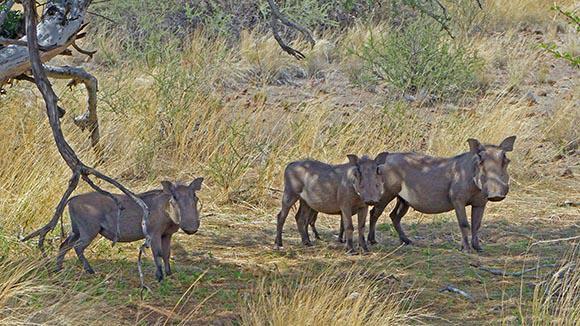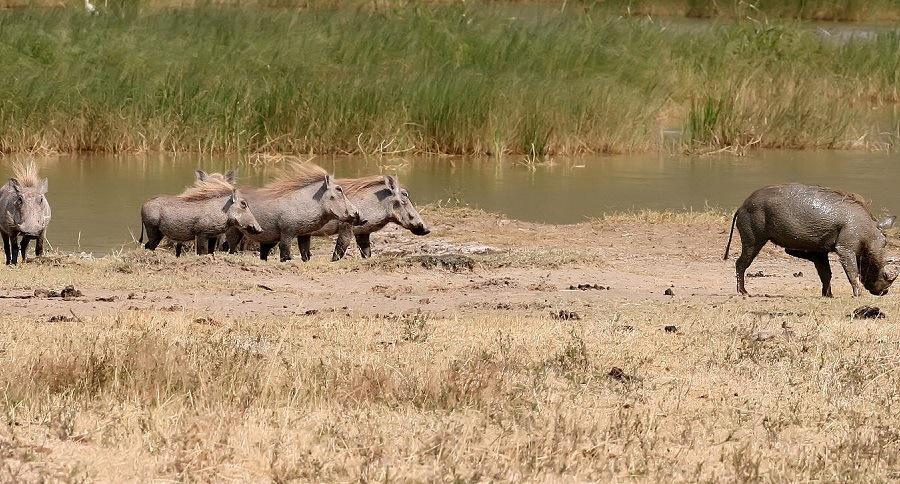The first image is the image on the left, the second image is the image on the right. Analyze the images presented: Is the assertion "one of the images shows a group of hogs standing and facing right." valid? Answer yes or no. Yes. The first image is the image on the left, the second image is the image on the right. Examine the images to the left and right. Is the description "There are 4 warthogs in the left image." accurate? Answer yes or no. No. 